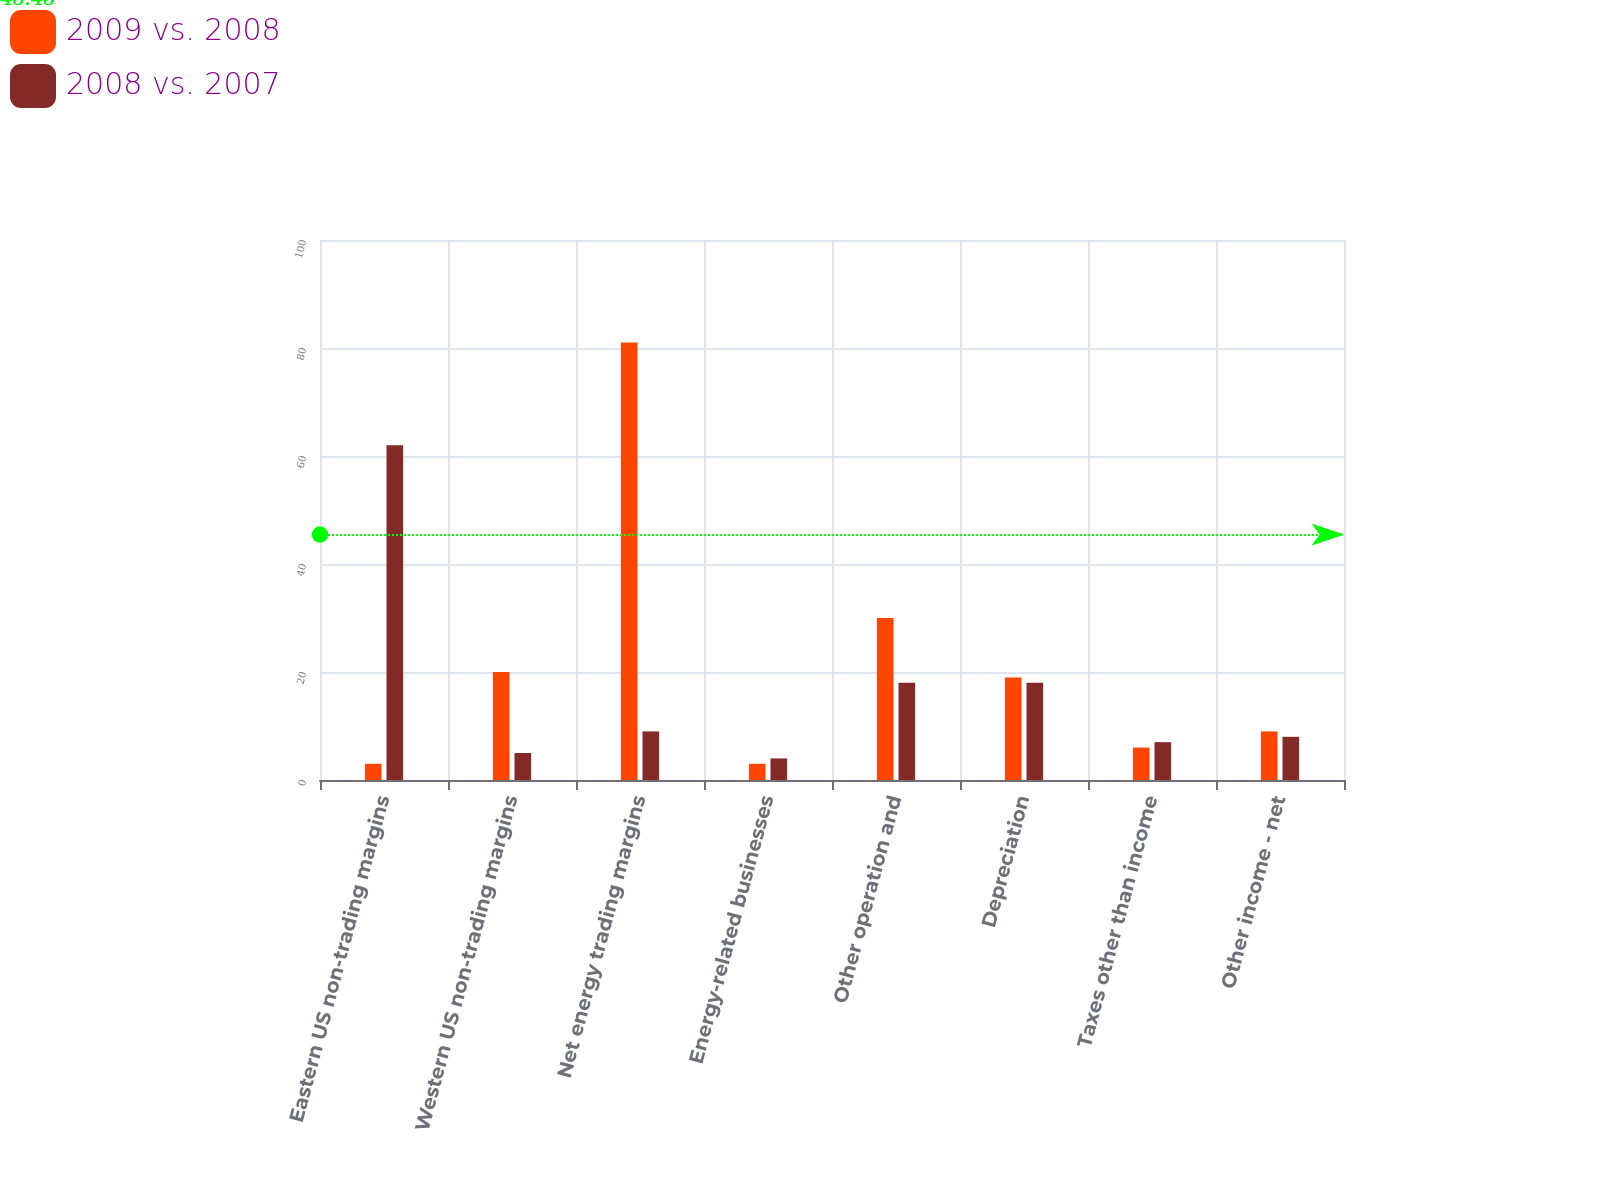<chart> <loc_0><loc_0><loc_500><loc_500><stacked_bar_chart><ecel><fcel>Eastern US non-trading margins<fcel>Western US non-trading margins<fcel>Net energy trading margins<fcel>Energy-related businesses<fcel>Other operation and<fcel>Depreciation<fcel>Taxes other than income<fcel>Other income - net<nl><fcel>2009 vs. 2008<fcel>3<fcel>20<fcel>81<fcel>3<fcel>30<fcel>19<fcel>6<fcel>9<nl><fcel>2008 vs. 2007<fcel>62<fcel>5<fcel>9<fcel>4<fcel>18<fcel>18<fcel>7<fcel>8<nl></chart> 